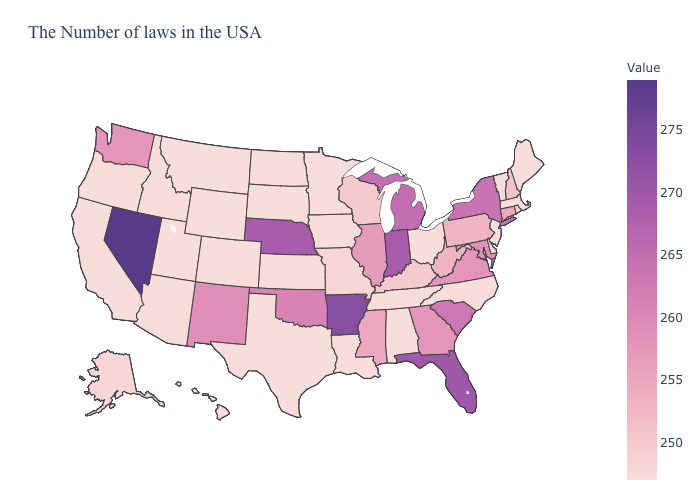Does the map have missing data?
Quick response, please. No. Is the legend a continuous bar?
Answer briefly. Yes. Does Arkansas have the highest value in the South?
Be succinct. Yes. Which states have the lowest value in the West?
Give a very brief answer. Wyoming, Colorado, Utah, Montana, Arizona, Idaho, California, Oregon, Hawaii. Among the states that border North Carolina , does Tennessee have the highest value?
Write a very short answer. No. Which states have the lowest value in the USA?
Write a very short answer. Maine, Massachusetts, Rhode Island, Vermont, New Jersey, Delaware, North Carolina, Ohio, Alabama, Tennessee, Louisiana, Minnesota, Iowa, Kansas, Texas, South Dakota, North Dakota, Wyoming, Colorado, Utah, Montana, Arizona, Idaho, California, Oregon, Hawaii. 